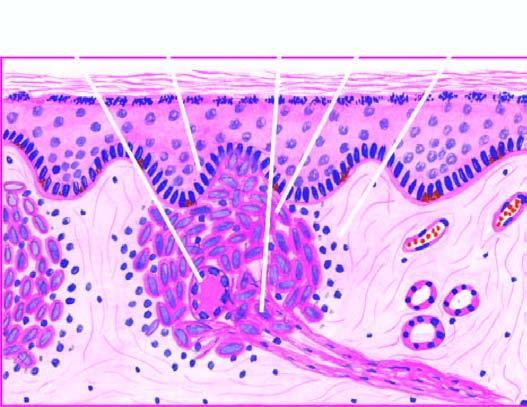what is the granuloma composed of?
Answer the question using a single word or phrase. Epithelioid cells with sparse langhans ' giant cells and lymphocytes 